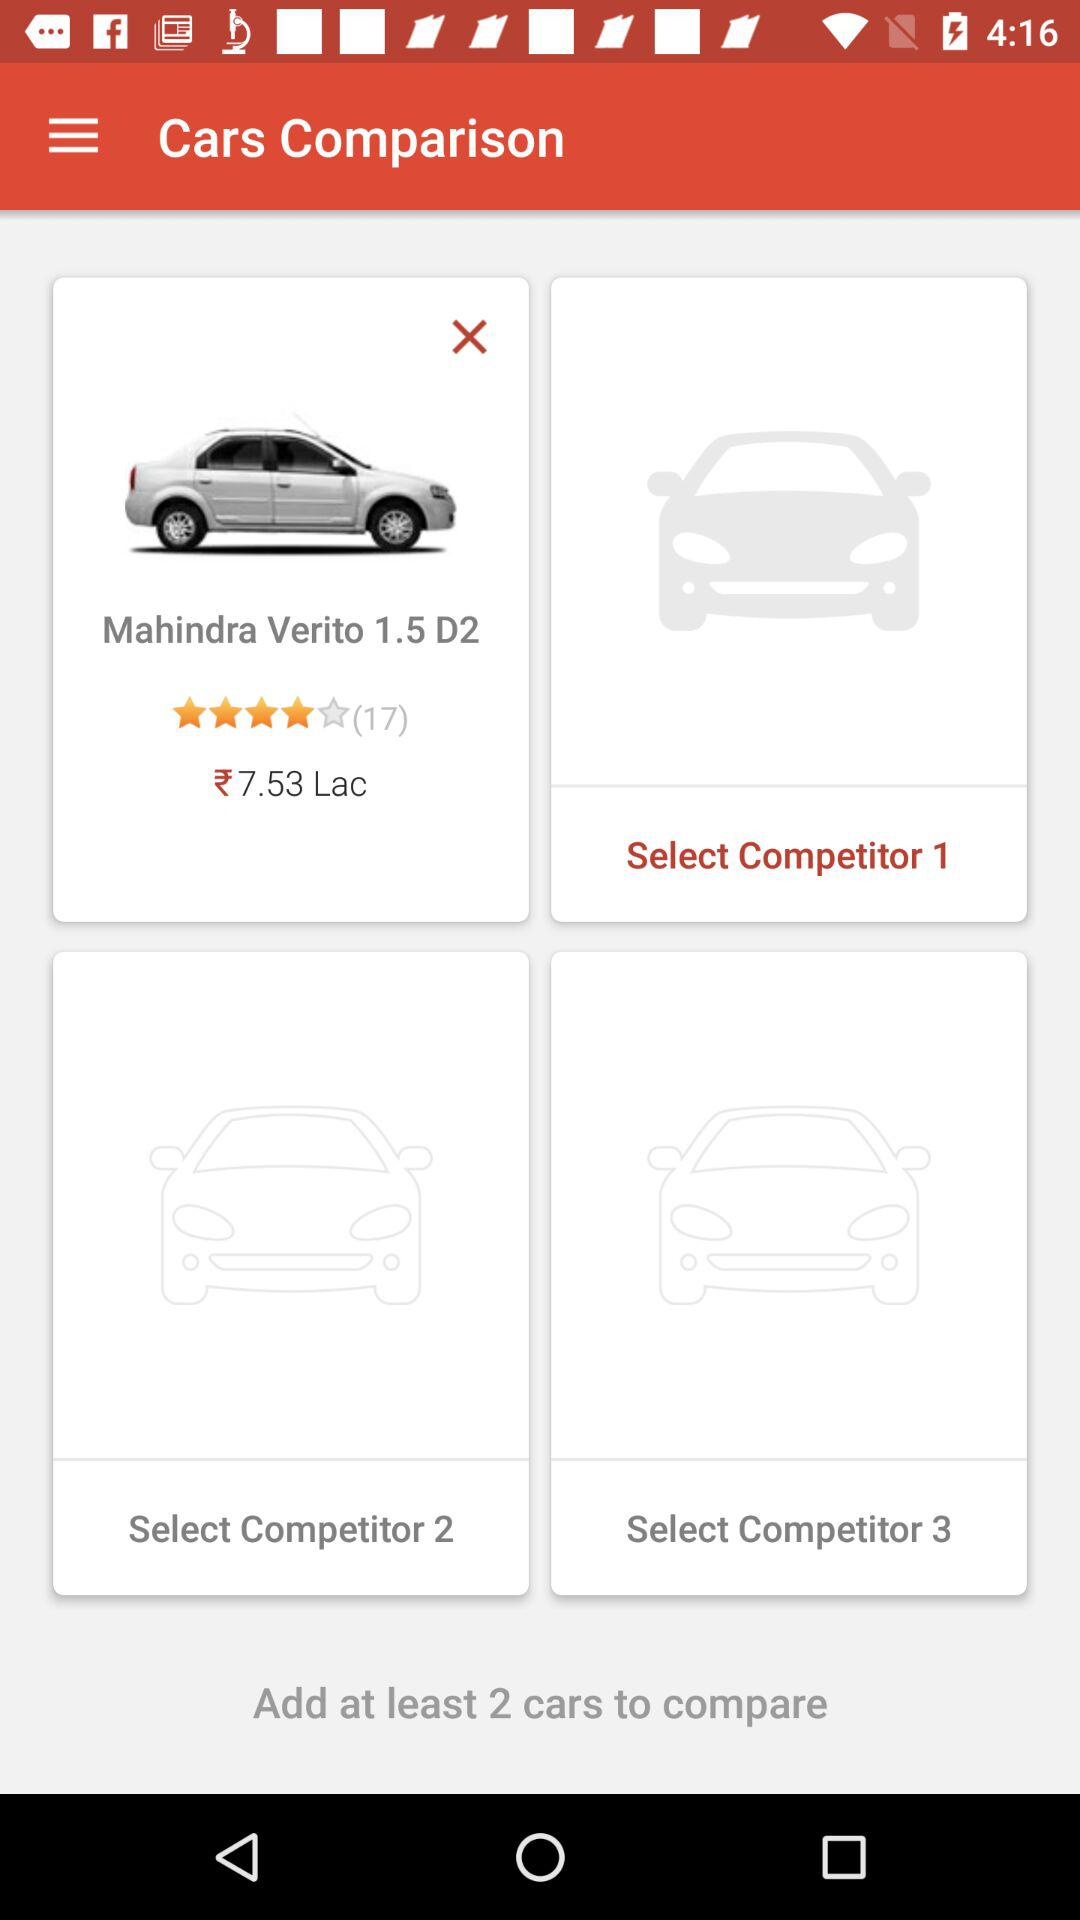What is the rating of the Mahindra Verito? The rating of the Mahindra Verito is 4 stars. 